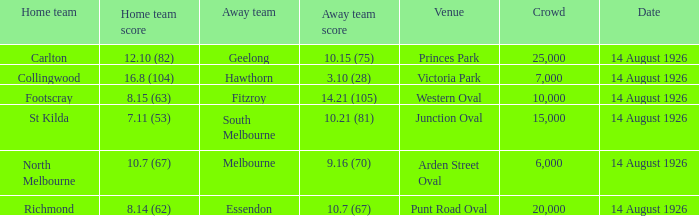What was the smallest gathering that observed an away team score 7000.0. 